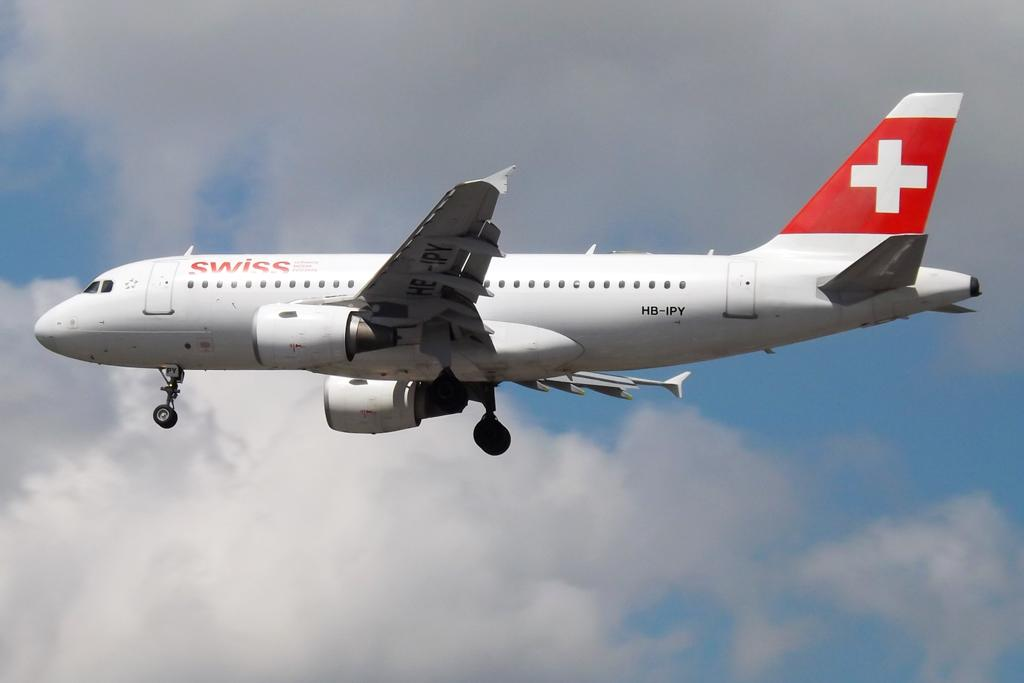<image>
Relay a brief, clear account of the picture shown. a white and red swiss airlines airplane in mid flight. 